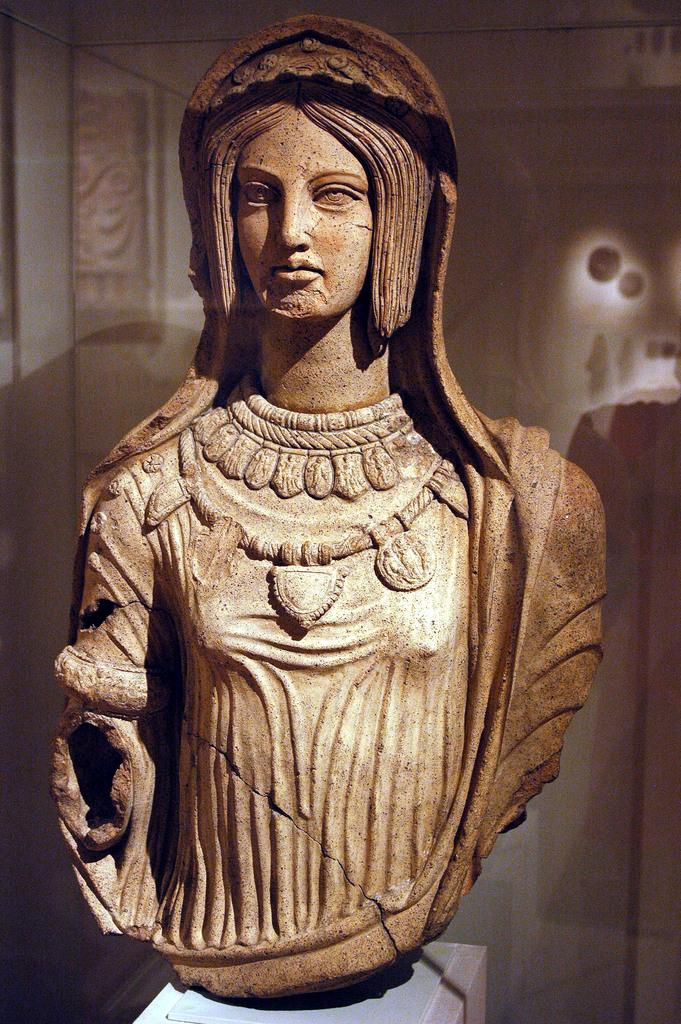What is the main subject of the image? There is a statue of a person in the image. What is the color of the statue? The statue is brown in color. What can be seen in the background of the image? There is a glass element visible in the background of the image. How many bees are sitting on the statue in the image? There are no bees present in the image; it only features a statue of a person and a glass element in the background. 